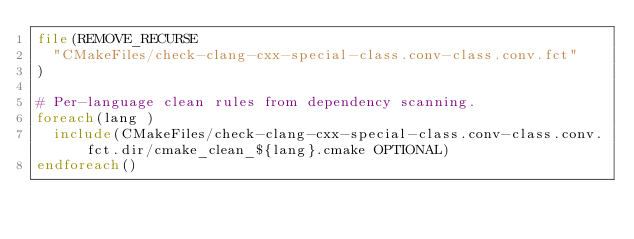Convert code to text. <code><loc_0><loc_0><loc_500><loc_500><_CMake_>file(REMOVE_RECURSE
  "CMakeFiles/check-clang-cxx-special-class.conv-class.conv.fct"
)

# Per-language clean rules from dependency scanning.
foreach(lang )
  include(CMakeFiles/check-clang-cxx-special-class.conv-class.conv.fct.dir/cmake_clean_${lang}.cmake OPTIONAL)
endforeach()
</code> 